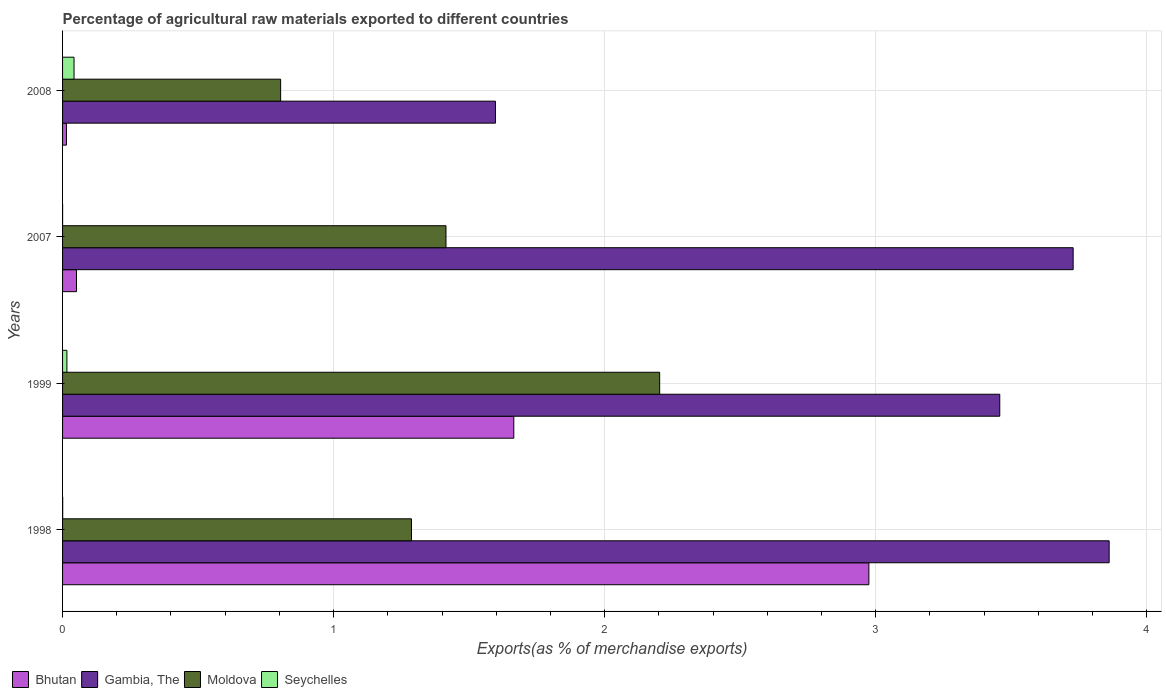Are the number of bars on each tick of the Y-axis equal?
Give a very brief answer. Yes. How many bars are there on the 3rd tick from the top?
Your response must be concise. 4. What is the label of the 1st group of bars from the top?
Offer a terse response. 2008. What is the percentage of exports to different countries in Bhutan in 1999?
Your answer should be very brief. 1.66. Across all years, what is the maximum percentage of exports to different countries in Moldova?
Offer a very short reply. 2.2. Across all years, what is the minimum percentage of exports to different countries in Gambia, The?
Ensure brevity in your answer.  1.6. In which year was the percentage of exports to different countries in Moldova maximum?
Your answer should be very brief. 1999. What is the total percentage of exports to different countries in Bhutan in the graph?
Offer a very short reply. 4.71. What is the difference between the percentage of exports to different countries in Moldova in 1999 and that in 2008?
Ensure brevity in your answer.  1.4. What is the difference between the percentage of exports to different countries in Moldova in 1998 and the percentage of exports to different countries in Seychelles in 2007?
Provide a succinct answer. 1.29. What is the average percentage of exports to different countries in Bhutan per year?
Make the answer very short. 1.18. In the year 2007, what is the difference between the percentage of exports to different countries in Moldova and percentage of exports to different countries in Gambia, The?
Provide a short and direct response. -2.31. In how many years, is the percentage of exports to different countries in Seychelles greater than 0.4 %?
Provide a succinct answer. 0. What is the ratio of the percentage of exports to different countries in Bhutan in 1999 to that in 2008?
Your answer should be compact. 115.96. Is the difference between the percentage of exports to different countries in Moldova in 1998 and 1999 greater than the difference between the percentage of exports to different countries in Gambia, The in 1998 and 1999?
Provide a short and direct response. No. What is the difference between the highest and the second highest percentage of exports to different countries in Seychelles?
Provide a short and direct response. 0.03. What is the difference between the highest and the lowest percentage of exports to different countries in Bhutan?
Offer a very short reply. 2.96. Is the sum of the percentage of exports to different countries in Seychelles in 1999 and 2008 greater than the maximum percentage of exports to different countries in Bhutan across all years?
Offer a terse response. No. Is it the case that in every year, the sum of the percentage of exports to different countries in Moldova and percentage of exports to different countries in Bhutan is greater than the sum of percentage of exports to different countries in Seychelles and percentage of exports to different countries in Gambia, The?
Offer a terse response. No. What does the 2nd bar from the top in 2008 represents?
Your response must be concise. Moldova. What does the 1st bar from the bottom in 1999 represents?
Ensure brevity in your answer.  Bhutan. Are all the bars in the graph horizontal?
Offer a very short reply. Yes. Where does the legend appear in the graph?
Provide a short and direct response. Bottom left. What is the title of the graph?
Your response must be concise. Percentage of agricultural raw materials exported to different countries. What is the label or title of the X-axis?
Make the answer very short. Exports(as % of merchandise exports). What is the Exports(as % of merchandise exports) of Bhutan in 1998?
Give a very brief answer. 2.98. What is the Exports(as % of merchandise exports) in Gambia, The in 1998?
Your response must be concise. 3.86. What is the Exports(as % of merchandise exports) in Moldova in 1998?
Provide a short and direct response. 1.29. What is the Exports(as % of merchandise exports) of Seychelles in 1998?
Ensure brevity in your answer.  0. What is the Exports(as % of merchandise exports) in Bhutan in 1999?
Give a very brief answer. 1.66. What is the Exports(as % of merchandise exports) of Gambia, The in 1999?
Keep it short and to the point. 3.46. What is the Exports(as % of merchandise exports) of Moldova in 1999?
Offer a terse response. 2.2. What is the Exports(as % of merchandise exports) of Seychelles in 1999?
Keep it short and to the point. 0.02. What is the Exports(as % of merchandise exports) in Bhutan in 2007?
Provide a short and direct response. 0.05. What is the Exports(as % of merchandise exports) in Gambia, The in 2007?
Offer a terse response. 3.73. What is the Exports(as % of merchandise exports) of Moldova in 2007?
Provide a succinct answer. 1.41. What is the Exports(as % of merchandise exports) in Seychelles in 2007?
Offer a terse response. 7.8789934352026e-5. What is the Exports(as % of merchandise exports) of Bhutan in 2008?
Offer a very short reply. 0.01. What is the Exports(as % of merchandise exports) in Gambia, The in 2008?
Your answer should be compact. 1.6. What is the Exports(as % of merchandise exports) of Moldova in 2008?
Make the answer very short. 0.8. What is the Exports(as % of merchandise exports) of Seychelles in 2008?
Offer a terse response. 0.04. Across all years, what is the maximum Exports(as % of merchandise exports) of Bhutan?
Provide a short and direct response. 2.98. Across all years, what is the maximum Exports(as % of merchandise exports) in Gambia, The?
Offer a terse response. 3.86. Across all years, what is the maximum Exports(as % of merchandise exports) of Moldova?
Ensure brevity in your answer.  2.2. Across all years, what is the maximum Exports(as % of merchandise exports) of Seychelles?
Keep it short and to the point. 0.04. Across all years, what is the minimum Exports(as % of merchandise exports) in Bhutan?
Offer a very short reply. 0.01. Across all years, what is the minimum Exports(as % of merchandise exports) of Gambia, The?
Your response must be concise. 1.6. Across all years, what is the minimum Exports(as % of merchandise exports) in Moldova?
Offer a terse response. 0.8. Across all years, what is the minimum Exports(as % of merchandise exports) in Seychelles?
Your response must be concise. 7.8789934352026e-5. What is the total Exports(as % of merchandise exports) in Bhutan in the graph?
Offer a very short reply. 4.71. What is the total Exports(as % of merchandise exports) of Gambia, The in the graph?
Keep it short and to the point. 12.65. What is the total Exports(as % of merchandise exports) of Moldova in the graph?
Your answer should be very brief. 5.71. What is the total Exports(as % of merchandise exports) of Seychelles in the graph?
Make the answer very short. 0.06. What is the difference between the Exports(as % of merchandise exports) in Bhutan in 1998 and that in 1999?
Your response must be concise. 1.31. What is the difference between the Exports(as % of merchandise exports) of Gambia, The in 1998 and that in 1999?
Keep it short and to the point. 0.4. What is the difference between the Exports(as % of merchandise exports) of Moldova in 1998 and that in 1999?
Your response must be concise. -0.92. What is the difference between the Exports(as % of merchandise exports) of Seychelles in 1998 and that in 1999?
Your answer should be very brief. -0.02. What is the difference between the Exports(as % of merchandise exports) of Bhutan in 1998 and that in 2007?
Offer a terse response. 2.92. What is the difference between the Exports(as % of merchandise exports) in Gambia, The in 1998 and that in 2007?
Provide a succinct answer. 0.13. What is the difference between the Exports(as % of merchandise exports) of Moldova in 1998 and that in 2007?
Provide a short and direct response. -0.13. What is the difference between the Exports(as % of merchandise exports) in Bhutan in 1998 and that in 2008?
Keep it short and to the point. 2.96. What is the difference between the Exports(as % of merchandise exports) of Gambia, The in 1998 and that in 2008?
Your answer should be very brief. 2.26. What is the difference between the Exports(as % of merchandise exports) of Moldova in 1998 and that in 2008?
Keep it short and to the point. 0.48. What is the difference between the Exports(as % of merchandise exports) of Seychelles in 1998 and that in 2008?
Your response must be concise. -0.04. What is the difference between the Exports(as % of merchandise exports) in Bhutan in 1999 and that in 2007?
Give a very brief answer. 1.61. What is the difference between the Exports(as % of merchandise exports) in Gambia, The in 1999 and that in 2007?
Your response must be concise. -0.27. What is the difference between the Exports(as % of merchandise exports) in Moldova in 1999 and that in 2007?
Provide a short and direct response. 0.79. What is the difference between the Exports(as % of merchandise exports) of Seychelles in 1999 and that in 2007?
Provide a succinct answer. 0.02. What is the difference between the Exports(as % of merchandise exports) of Bhutan in 1999 and that in 2008?
Your response must be concise. 1.65. What is the difference between the Exports(as % of merchandise exports) of Gambia, The in 1999 and that in 2008?
Provide a succinct answer. 1.86. What is the difference between the Exports(as % of merchandise exports) in Moldova in 1999 and that in 2008?
Ensure brevity in your answer.  1.4. What is the difference between the Exports(as % of merchandise exports) in Seychelles in 1999 and that in 2008?
Your response must be concise. -0.03. What is the difference between the Exports(as % of merchandise exports) in Bhutan in 2007 and that in 2008?
Your response must be concise. 0.04. What is the difference between the Exports(as % of merchandise exports) of Gambia, The in 2007 and that in 2008?
Provide a succinct answer. 2.13. What is the difference between the Exports(as % of merchandise exports) in Moldova in 2007 and that in 2008?
Make the answer very short. 0.61. What is the difference between the Exports(as % of merchandise exports) in Seychelles in 2007 and that in 2008?
Your answer should be very brief. -0.04. What is the difference between the Exports(as % of merchandise exports) of Bhutan in 1998 and the Exports(as % of merchandise exports) of Gambia, The in 1999?
Provide a short and direct response. -0.48. What is the difference between the Exports(as % of merchandise exports) of Bhutan in 1998 and the Exports(as % of merchandise exports) of Moldova in 1999?
Keep it short and to the point. 0.77. What is the difference between the Exports(as % of merchandise exports) in Bhutan in 1998 and the Exports(as % of merchandise exports) in Seychelles in 1999?
Your response must be concise. 2.96. What is the difference between the Exports(as % of merchandise exports) of Gambia, The in 1998 and the Exports(as % of merchandise exports) of Moldova in 1999?
Give a very brief answer. 1.66. What is the difference between the Exports(as % of merchandise exports) of Gambia, The in 1998 and the Exports(as % of merchandise exports) of Seychelles in 1999?
Offer a terse response. 3.85. What is the difference between the Exports(as % of merchandise exports) in Moldova in 1998 and the Exports(as % of merchandise exports) in Seychelles in 1999?
Offer a very short reply. 1.27. What is the difference between the Exports(as % of merchandise exports) in Bhutan in 1998 and the Exports(as % of merchandise exports) in Gambia, The in 2007?
Keep it short and to the point. -0.75. What is the difference between the Exports(as % of merchandise exports) of Bhutan in 1998 and the Exports(as % of merchandise exports) of Moldova in 2007?
Keep it short and to the point. 1.56. What is the difference between the Exports(as % of merchandise exports) of Bhutan in 1998 and the Exports(as % of merchandise exports) of Seychelles in 2007?
Provide a short and direct response. 2.98. What is the difference between the Exports(as % of merchandise exports) of Gambia, The in 1998 and the Exports(as % of merchandise exports) of Moldova in 2007?
Offer a very short reply. 2.45. What is the difference between the Exports(as % of merchandise exports) of Gambia, The in 1998 and the Exports(as % of merchandise exports) of Seychelles in 2007?
Your response must be concise. 3.86. What is the difference between the Exports(as % of merchandise exports) in Moldova in 1998 and the Exports(as % of merchandise exports) in Seychelles in 2007?
Ensure brevity in your answer.  1.29. What is the difference between the Exports(as % of merchandise exports) in Bhutan in 1998 and the Exports(as % of merchandise exports) in Gambia, The in 2008?
Offer a very short reply. 1.38. What is the difference between the Exports(as % of merchandise exports) of Bhutan in 1998 and the Exports(as % of merchandise exports) of Moldova in 2008?
Offer a terse response. 2.17. What is the difference between the Exports(as % of merchandise exports) of Bhutan in 1998 and the Exports(as % of merchandise exports) of Seychelles in 2008?
Ensure brevity in your answer.  2.93. What is the difference between the Exports(as % of merchandise exports) of Gambia, The in 1998 and the Exports(as % of merchandise exports) of Moldova in 2008?
Provide a short and direct response. 3.06. What is the difference between the Exports(as % of merchandise exports) of Gambia, The in 1998 and the Exports(as % of merchandise exports) of Seychelles in 2008?
Make the answer very short. 3.82. What is the difference between the Exports(as % of merchandise exports) of Moldova in 1998 and the Exports(as % of merchandise exports) of Seychelles in 2008?
Provide a succinct answer. 1.25. What is the difference between the Exports(as % of merchandise exports) of Bhutan in 1999 and the Exports(as % of merchandise exports) of Gambia, The in 2007?
Provide a succinct answer. -2.06. What is the difference between the Exports(as % of merchandise exports) in Bhutan in 1999 and the Exports(as % of merchandise exports) in Moldova in 2007?
Provide a short and direct response. 0.25. What is the difference between the Exports(as % of merchandise exports) in Bhutan in 1999 and the Exports(as % of merchandise exports) in Seychelles in 2007?
Your response must be concise. 1.66. What is the difference between the Exports(as % of merchandise exports) of Gambia, The in 1999 and the Exports(as % of merchandise exports) of Moldova in 2007?
Keep it short and to the point. 2.04. What is the difference between the Exports(as % of merchandise exports) in Gambia, The in 1999 and the Exports(as % of merchandise exports) in Seychelles in 2007?
Provide a short and direct response. 3.46. What is the difference between the Exports(as % of merchandise exports) in Moldova in 1999 and the Exports(as % of merchandise exports) in Seychelles in 2007?
Make the answer very short. 2.2. What is the difference between the Exports(as % of merchandise exports) of Bhutan in 1999 and the Exports(as % of merchandise exports) of Gambia, The in 2008?
Provide a succinct answer. 0.07. What is the difference between the Exports(as % of merchandise exports) in Bhutan in 1999 and the Exports(as % of merchandise exports) in Moldova in 2008?
Your response must be concise. 0.86. What is the difference between the Exports(as % of merchandise exports) of Bhutan in 1999 and the Exports(as % of merchandise exports) of Seychelles in 2008?
Your answer should be compact. 1.62. What is the difference between the Exports(as % of merchandise exports) of Gambia, The in 1999 and the Exports(as % of merchandise exports) of Moldova in 2008?
Give a very brief answer. 2.65. What is the difference between the Exports(as % of merchandise exports) of Gambia, The in 1999 and the Exports(as % of merchandise exports) of Seychelles in 2008?
Offer a very short reply. 3.42. What is the difference between the Exports(as % of merchandise exports) in Moldova in 1999 and the Exports(as % of merchandise exports) in Seychelles in 2008?
Provide a succinct answer. 2.16. What is the difference between the Exports(as % of merchandise exports) in Bhutan in 2007 and the Exports(as % of merchandise exports) in Gambia, The in 2008?
Your response must be concise. -1.55. What is the difference between the Exports(as % of merchandise exports) in Bhutan in 2007 and the Exports(as % of merchandise exports) in Moldova in 2008?
Make the answer very short. -0.75. What is the difference between the Exports(as % of merchandise exports) in Bhutan in 2007 and the Exports(as % of merchandise exports) in Seychelles in 2008?
Your answer should be compact. 0.01. What is the difference between the Exports(as % of merchandise exports) of Gambia, The in 2007 and the Exports(as % of merchandise exports) of Moldova in 2008?
Give a very brief answer. 2.92. What is the difference between the Exports(as % of merchandise exports) of Gambia, The in 2007 and the Exports(as % of merchandise exports) of Seychelles in 2008?
Your response must be concise. 3.69. What is the difference between the Exports(as % of merchandise exports) in Moldova in 2007 and the Exports(as % of merchandise exports) in Seychelles in 2008?
Ensure brevity in your answer.  1.37. What is the average Exports(as % of merchandise exports) of Bhutan per year?
Give a very brief answer. 1.18. What is the average Exports(as % of merchandise exports) in Gambia, The per year?
Provide a succinct answer. 3.16. What is the average Exports(as % of merchandise exports) in Moldova per year?
Offer a very short reply. 1.43. What is the average Exports(as % of merchandise exports) of Seychelles per year?
Provide a short and direct response. 0.01. In the year 1998, what is the difference between the Exports(as % of merchandise exports) of Bhutan and Exports(as % of merchandise exports) of Gambia, The?
Give a very brief answer. -0.89. In the year 1998, what is the difference between the Exports(as % of merchandise exports) in Bhutan and Exports(as % of merchandise exports) in Moldova?
Provide a short and direct response. 1.69. In the year 1998, what is the difference between the Exports(as % of merchandise exports) of Bhutan and Exports(as % of merchandise exports) of Seychelles?
Keep it short and to the point. 2.97. In the year 1998, what is the difference between the Exports(as % of merchandise exports) of Gambia, The and Exports(as % of merchandise exports) of Moldova?
Offer a terse response. 2.57. In the year 1998, what is the difference between the Exports(as % of merchandise exports) of Gambia, The and Exports(as % of merchandise exports) of Seychelles?
Your response must be concise. 3.86. In the year 1998, what is the difference between the Exports(as % of merchandise exports) in Moldova and Exports(as % of merchandise exports) in Seychelles?
Offer a terse response. 1.29. In the year 1999, what is the difference between the Exports(as % of merchandise exports) in Bhutan and Exports(as % of merchandise exports) in Gambia, The?
Offer a very short reply. -1.79. In the year 1999, what is the difference between the Exports(as % of merchandise exports) in Bhutan and Exports(as % of merchandise exports) in Moldova?
Your answer should be compact. -0.54. In the year 1999, what is the difference between the Exports(as % of merchandise exports) of Bhutan and Exports(as % of merchandise exports) of Seychelles?
Keep it short and to the point. 1.65. In the year 1999, what is the difference between the Exports(as % of merchandise exports) in Gambia, The and Exports(as % of merchandise exports) in Moldova?
Make the answer very short. 1.25. In the year 1999, what is the difference between the Exports(as % of merchandise exports) of Gambia, The and Exports(as % of merchandise exports) of Seychelles?
Your answer should be very brief. 3.44. In the year 1999, what is the difference between the Exports(as % of merchandise exports) of Moldova and Exports(as % of merchandise exports) of Seychelles?
Make the answer very short. 2.19. In the year 2007, what is the difference between the Exports(as % of merchandise exports) in Bhutan and Exports(as % of merchandise exports) in Gambia, The?
Your response must be concise. -3.68. In the year 2007, what is the difference between the Exports(as % of merchandise exports) of Bhutan and Exports(as % of merchandise exports) of Moldova?
Provide a succinct answer. -1.36. In the year 2007, what is the difference between the Exports(as % of merchandise exports) in Bhutan and Exports(as % of merchandise exports) in Seychelles?
Keep it short and to the point. 0.05. In the year 2007, what is the difference between the Exports(as % of merchandise exports) of Gambia, The and Exports(as % of merchandise exports) of Moldova?
Give a very brief answer. 2.31. In the year 2007, what is the difference between the Exports(as % of merchandise exports) of Gambia, The and Exports(as % of merchandise exports) of Seychelles?
Your answer should be compact. 3.73. In the year 2007, what is the difference between the Exports(as % of merchandise exports) in Moldova and Exports(as % of merchandise exports) in Seychelles?
Make the answer very short. 1.41. In the year 2008, what is the difference between the Exports(as % of merchandise exports) of Bhutan and Exports(as % of merchandise exports) of Gambia, The?
Offer a terse response. -1.58. In the year 2008, what is the difference between the Exports(as % of merchandise exports) of Bhutan and Exports(as % of merchandise exports) of Moldova?
Provide a succinct answer. -0.79. In the year 2008, what is the difference between the Exports(as % of merchandise exports) of Bhutan and Exports(as % of merchandise exports) of Seychelles?
Keep it short and to the point. -0.03. In the year 2008, what is the difference between the Exports(as % of merchandise exports) in Gambia, The and Exports(as % of merchandise exports) in Moldova?
Offer a terse response. 0.79. In the year 2008, what is the difference between the Exports(as % of merchandise exports) in Gambia, The and Exports(as % of merchandise exports) in Seychelles?
Your answer should be very brief. 1.55. In the year 2008, what is the difference between the Exports(as % of merchandise exports) of Moldova and Exports(as % of merchandise exports) of Seychelles?
Your answer should be compact. 0.76. What is the ratio of the Exports(as % of merchandise exports) in Bhutan in 1998 to that in 1999?
Your answer should be very brief. 1.79. What is the ratio of the Exports(as % of merchandise exports) of Gambia, The in 1998 to that in 1999?
Your answer should be compact. 1.12. What is the ratio of the Exports(as % of merchandise exports) in Moldova in 1998 to that in 1999?
Keep it short and to the point. 0.58. What is the ratio of the Exports(as % of merchandise exports) of Seychelles in 1998 to that in 1999?
Provide a succinct answer. 0.03. What is the ratio of the Exports(as % of merchandise exports) in Bhutan in 1998 to that in 2007?
Offer a terse response. 57.84. What is the ratio of the Exports(as % of merchandise exports) of Gambia, The in 1998 to that in 2007?
Offer a very short reply. 1.04. What is the ratio of the Exports(as % of merchandise exports) of Moldova in 1998 to that in 2007?
Provide a short and direct response. 0.91. What is the ratio of the Exports(as % of merchandise exports) of Seychelles in 1998 to that in 2007?
Offer a terse response. 5.64. What is the ratio of the Exports(as % of merchandise exports) of Bhutan in 1998 to that in 2008?
Your answer should be very brief. 207.21. What is the ratio of the Exports(as % of merchandise exports) of Gambia, The in 1998 to that in 2008?
Keep it short and to the point. 2.42. What is the ratio of the Exports(as % of merchandise exports) of Moldova in 1998 to that in 2008?
Make the answer very short. 1.6. What is the ratio of the Exports(as % of merchandise exports) in Seychelles in 1998 to that in 2008?
Your answer should be very brief. 0.01. What is the ratio of the Exports(as % of merchandise exports) of Bhutan in 1999 to that in 2007?
Ensure brevity in your answer.  32.37. What is the ratio of the Exports(as % of merchandise exports) of Gambia, The in 1999 to that in 2007?
Offer a very short reply. 0.93. What is the ratio of the Exports(as % of merchandise exports) of Moldova in 1999 to that in 2007?
Offer a very short reply. 1.56. What is the ratio of the Exports(as % of merchandise exports) in Seychelles in 1999 to that in 2007?
Provide a short and direct response. 203.1. What is the ratio of the Exports(as % of merchandise exports) of Bhutan in 1999 to that in 2008?
Your answer should be compact. 115.96. What is the ratio of the Exports(as % of merchandise exports) of Gambia, The in 1999 to that in 2008?
Your answer should be very brief. 2.17. What is the ratio of the Exports(as % of merchandise exports) in Moldova in 1999 to that in 2008?
Offer a terse response. 2.74. What is the ratio of the Exports(as % of merchandise exports) of Seychelles in 1999 to that in 2008?
Ensure brevity in your answer.  0.38. What is the ratio of the Exports(as % of merchandise exports) of Bhutan in 2007 to that in 2008?
Give a very brief answer. 3.58. What is the ratio of the Exports(as % of merchandise exports) of Gambia, The in 2007 to that in 2008?
Ensure brevity in your answer.  2.33. What is the ratio of the Exports(as % of merchandise exports) of Moldova in 2007 to that in 2008?
Your answer should be very brief. 1.76. What is the ratio of the Exports(as % of merchandise exports) in Seychelles in 2007 to that in 2008?
Provide a short and direct response. 0. What is the difference between the highest and the second highest Exports(as % of merchandise exports) of Bhutan?
Make the answer very short. 1.31. What is the difference between the highest and the second highest Exports(as % of merchandise exports) in Gambia, The?
Your response must be concise. 0.13. What is the difference between the highest and the second highest Exports(as % of merchandise exports) of Moldova?
Provide a succinct answer. 0.79. What is the difference between the highest and the second highest Exports(as % of merchandise exports) in Seychelles?
Your answer should be compact. 0.03. What is the difference between the highest and the lowest Exports(as % of merchandise exports) in Bhutan?
Provide a succinct answer. 2.96. What is the difference between the highest and the lowest Exports(as % of merchandise exports) of Gambia, The?
Keep it short and to the point. 2.26. What is the difference between the highest and the lowest Exports(as % of merchandise exports) in Moldova?
Your answer should be compact. 1.4. What is the difference between the highest and the lowest Exports(as % of merchandise exports) of Seychelles?
Your answer should be very brief. 0.04. 